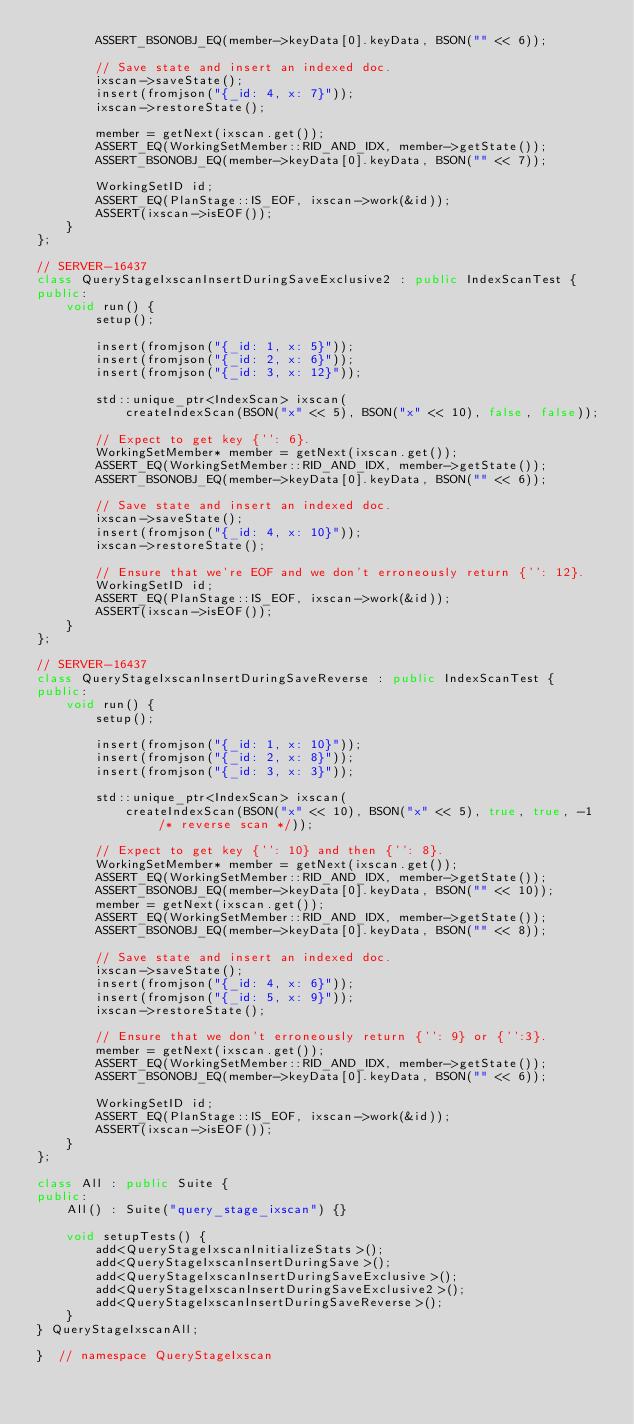<code> <loc_0><loc_0><loc_500><loc_500><_C++_>        ASSERT_BSONOBJ_EQ(member->keyData[0].keyData, BSON("" << 6));

        // Save state and insert an indexed doc.
        ixscan->saveState();
        insert(fromjson("{_id: 4, x: 7}"));
        ixscan->restoreState();

        member = getNext(ixscan.get());
        ASSERT_EQ(WorkingSetMember::RID_AND_IDX, member->getState());
        ASSERT_BSONOBJ_EQ(member->keyData[0].keyData, BSON("" << 7));

        WorkingSetID id;
        ASSERT_EQ(PlanStage::IS_EOF, ixscan->work(&id));
        ASSERT(ixscan->isEOF());
    }
};

// SERVER-16437
class QueryStageIxscanInsertDuringSaveExclusive2 : public IndexScanTest {
public:
    void run() {
        setup();

        insert(fromjson("{_id: 1, x: 5}"));
        insert(fromjson("{_id: 2, x: 6}"));
        insert(fromjson("{_id: 3, x: 12}"));

        std::unique_ptr<IndexScan> ixscan(
            createIndexScan(BSON("x" << 5), BSON("x" << 10), false, false));

        // Expect to get key {'': 6}.
        WorkingSetMember* member = getNext(ixscan.get());
        ASSERT_EQ(WorkingSetMember::RID_AND_IDX, member->getState());
        ASSERT_BSONOBJ_EQ(member->keyData[0].keyData, BSON("" << 6));

        // Save state and insert an indexed doc.
        ixscan->saveState();
        insert(fromjson("{_id: 4, x: 10}"));
        ixscan->restoreState();

        // Ensure that we're EOF and we don't erroneously return {'': 12}.
        WorkingSetID id;
        ASSERT_EQ(PlanStage::IS_EOF, ixscan->work(&id));
        ASSERT(ixscan->isEOF());
    }
};

// SERVER-16437
class QueryStageIxscanInsertDuringSaveReverse : public IndexScanTest {
public:
    void run() {
        setup();

        insert(fromjson("{_id: 1, x: 10}"));
        insert(fromjson("{_id: 2, x: 8}"));
        insert(fromjson("{_id: 3, x: 3}"));

        std::unique_ptr<IndexScan> ixscan(
            createIndexScan(BSON("x" << 10), BSON("x" << 5), true, true, -1 /* reverse scan */));

        // Expect to get key {'': 10} and then {'': 8}.
        WorkingSetMember* member = getNext(ixscan.get());
        ASSERT_EQ(WorkingSetMember::RID_AND_IDX, member->getState());
        ASSERT_BSONOBJ_EQ(member->keyData[0].keyData, BSON("" << 10));
        member = getNext(ixscan.get());
        ASSERT_EQ(WorkingSetMember::RID_AND_IDX, member->getState());
        ASSERT_BSONOBJ_EQ(member->keyData[0].keyData, BSON("" << 8));

        // Save state and insert an indexed doc.
        ixscan->saveState();
        insert(fromjson("{_id: 4, x: 6}"));
        insert(fromjson("{_id: 5, x: 9}"));
        ixscan->restoreState();

        // Ensure that we don't erroneously return {'': 9} or {'':3}.
        member = getNext(ixscan.get());
        ASSERT_EQ(WorkingSetMember::RID_AND_IDX, member->getState());
        ASSERT_BSONOBJ_EQ(member->keyData[0].keyData, BSON("" << 6));

        WorkingSetID id;
        ASSERT_EQ(PlanStage::IS_EOF, ixscan->work(&id));
        ASSERT(ixscan->isEOF());
    }
};

class All : public Suite {
public:
    All() : Suite("query_stage_ixscan") {}

    void setupTests() {
        add<QueryStageIxscanInitializeStats>();
        add<QueryStageIxscanInsertDuringSave>();
        add<QueryStageIxscanInsertDuringSaveExclusive>();
        add<QueryStageIxscanInsertDuringSaveExclusive2>();
        add<QueryStageIxscanInsertDuringSaveReverse>();
    }
} QueryStageIxscanAll;

}  // namespace QueryStageIxscan
</code> 